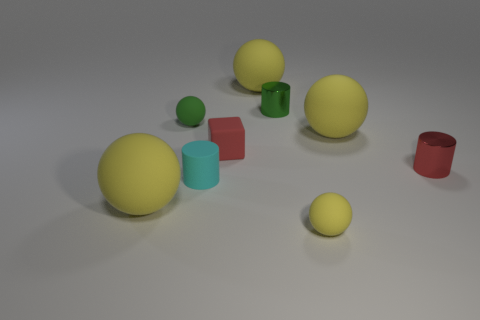How many yellow spheres must be subtracted to get 1 yellow spheres? 3 Subtract all purple cylinders. How many yellow balls are left? 4 Subtract 1 spheres. How many spheres are left? 4 Subtract all brown spheres. Subtract all purple cubes. How many spheres are left? 5 Add 1 red cylinders. How many objects exist? 10 Subtract all cylinders. How many objects are left? 6 Add 3 large cyan shiny spheres. How many large cyan shiny spheres exist? 3 Subtract 0 gray spheres. How many objects are left? 9 Subtract all purple cylinders. Subtract all metallic cylinders. How many objects are left? 7 Add 1 big things. How many big things are left? 4 